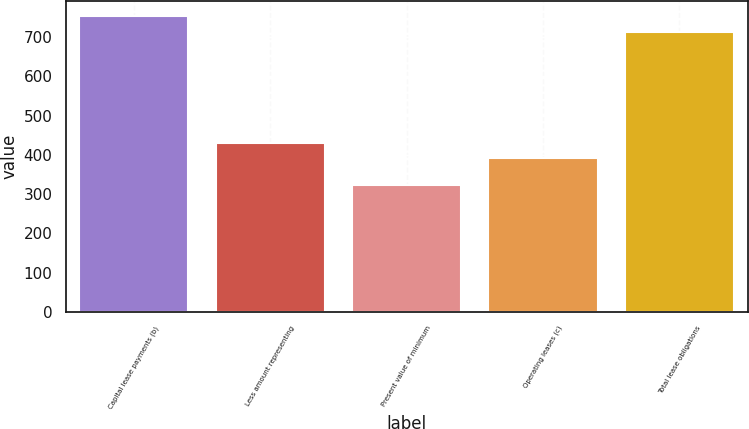Convert chart. <chart><loc_0><loc_0><loc_500><loc_500><bar_chart><fcel>Capital lease payments (b)<fcel>Less amount representing<fcel>Present value of minimum<fcel>Operating leases (c)<fcel>Total lease obligations<nl><fcel>753.5<fcel>431.5<fcel>322<fcel>392<fcel>714<nl></chart> 